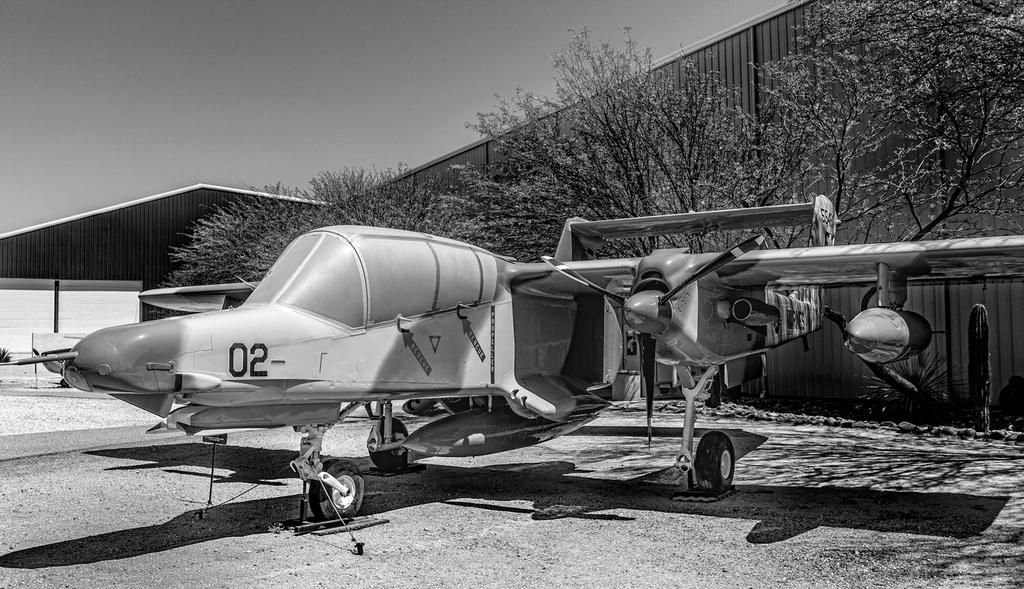<image>
Present a compact description of the photo's key features. The plane has the numbers "02" painted on top of it. 